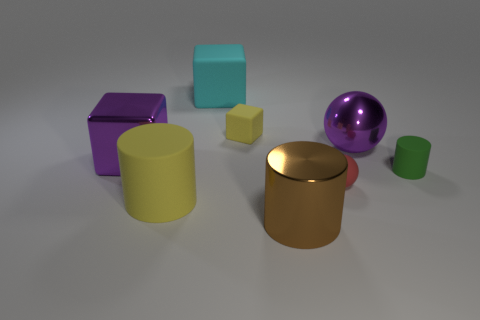Subtract all green cylinders. Subtract all red blocks. How many cylinders are left? 2 Add 1 yellow things. How many objects exist? 9 Subtract all cylinders. How many objects are left? 5 Add 5 large yellow metal cylinders. How many large yellow metal cylinders exist? 5 Subtract 1 purple balls. How many objects are left? 7 Subtract all large green metal balls. Subtract all big brown cylinders. How many objects are left? 7 Add 6 big brown things. How many big brown things are left? 7 